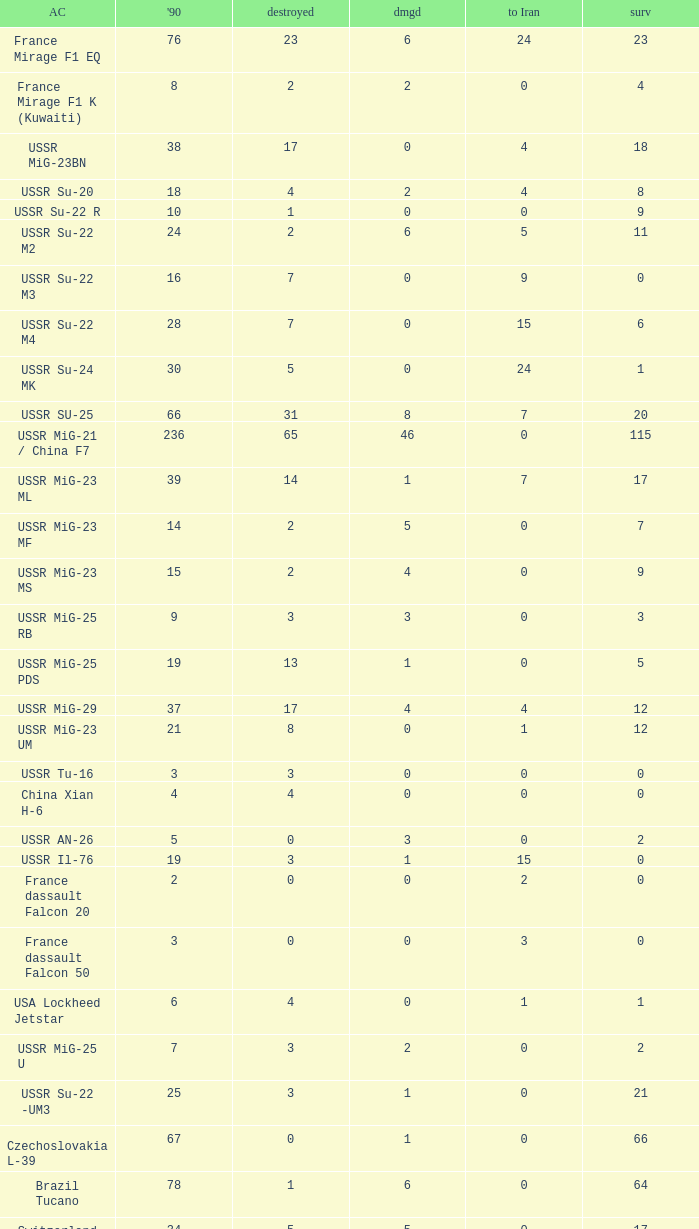If 4 went to iran and the amount that survived was less than 12.0 how many were there in 1990? 1.0. 